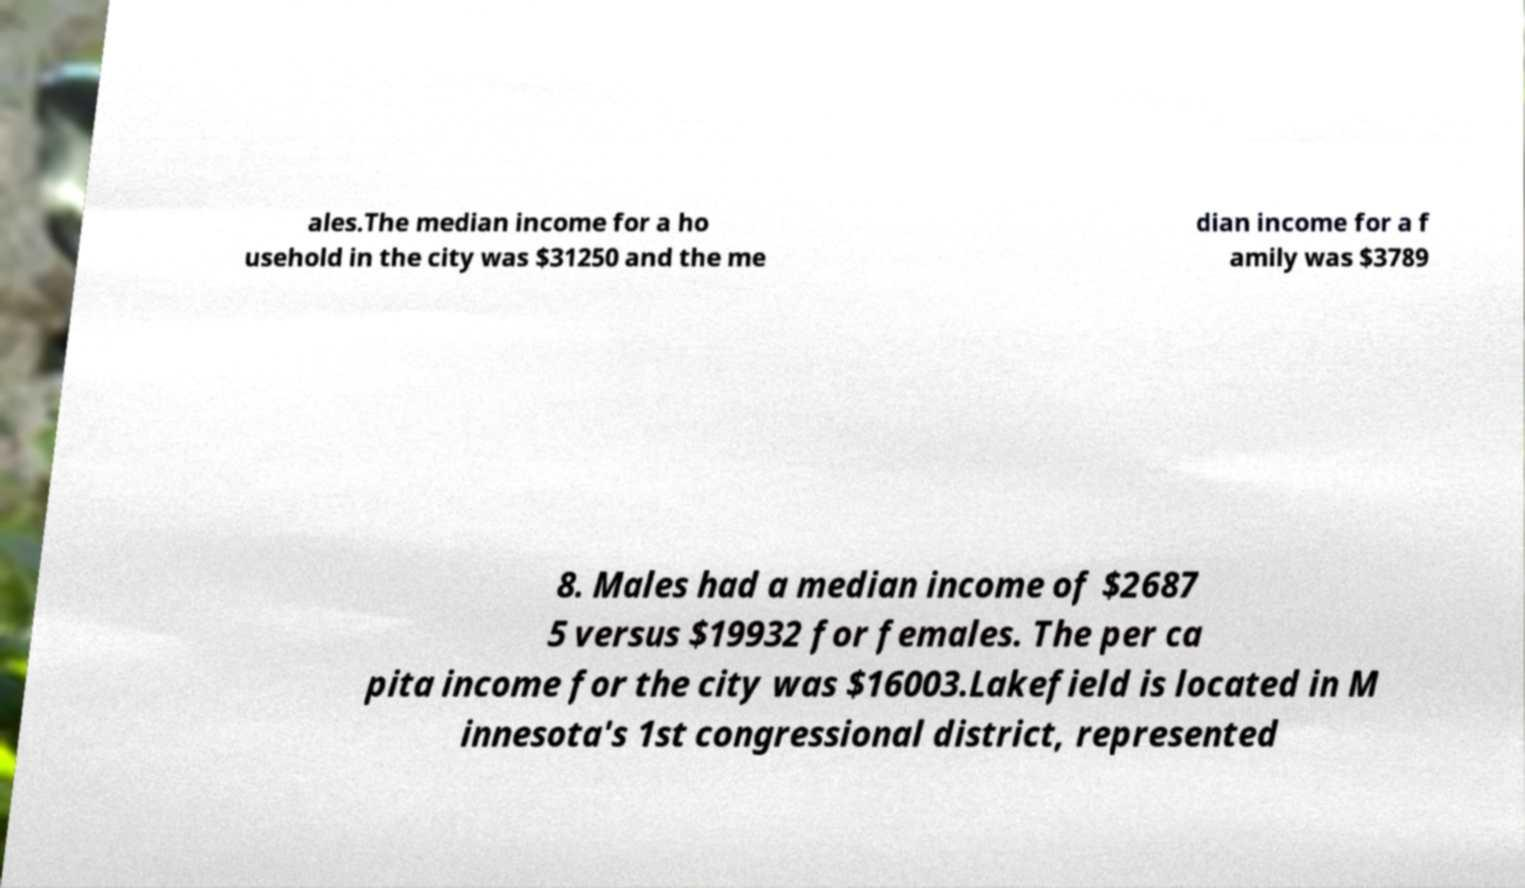Please identify and transcribe the text found in this image. ales.The median income for a ho usehold in the city was $31250 and the me dian income for a f amily was $3789 8. Males had a median income of $2687 5 versus $19932 for females. The per ca pita income for the city was $16003.Lakefield is located in M innesota's 1st congressional district, represented 